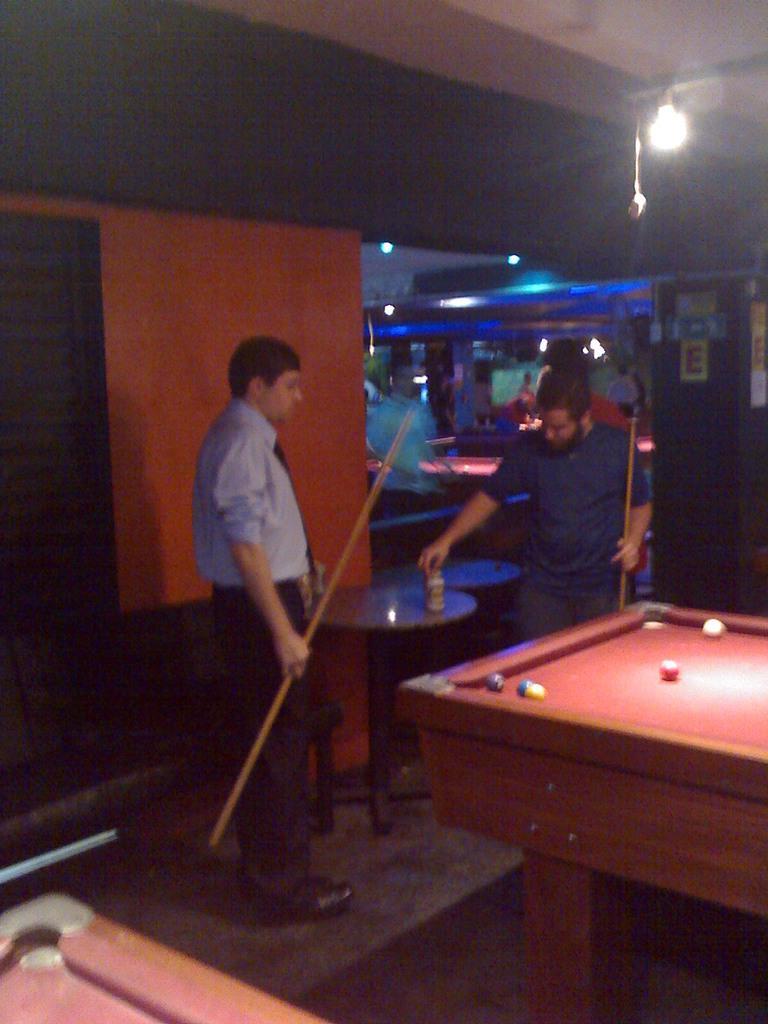Could you give a brief overview of what you see in this image? In this picture we have two people who are playing the snookers game and above there is a light. 